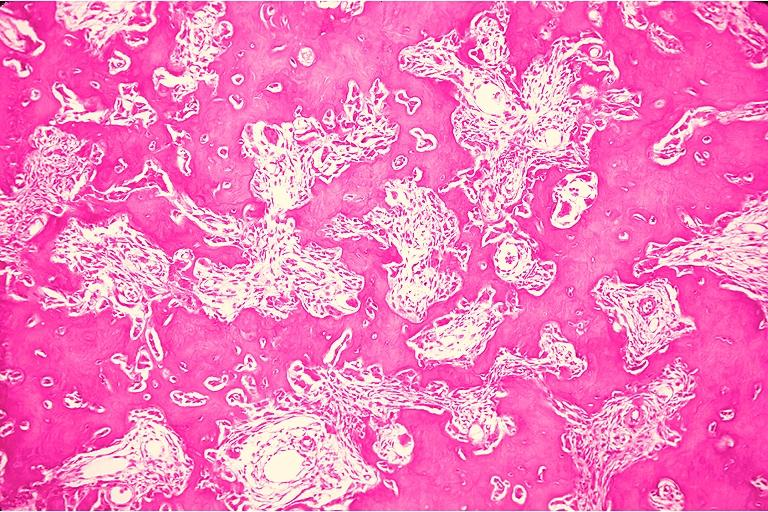s multiple myeloma present?
Answer the question using a single word or phrase. No 